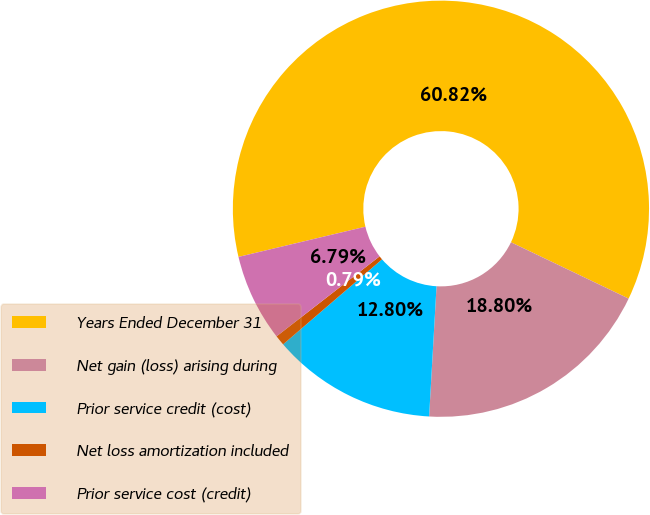<chart> <loc_0><loc_0><loc_500><loc_500><pie_chart><fcel>Years Ended December 31<fcel>Net gain (loss) arising during<fcel>Prior service credit (cost)<fcel>Net loss amortization included<fcel>Prior service cost (credit)<nl><fcel>60.83%<fcel>18.8%<fcel>12.8%<fcel>0.79%<fcel>6.79%<nl></chart> 